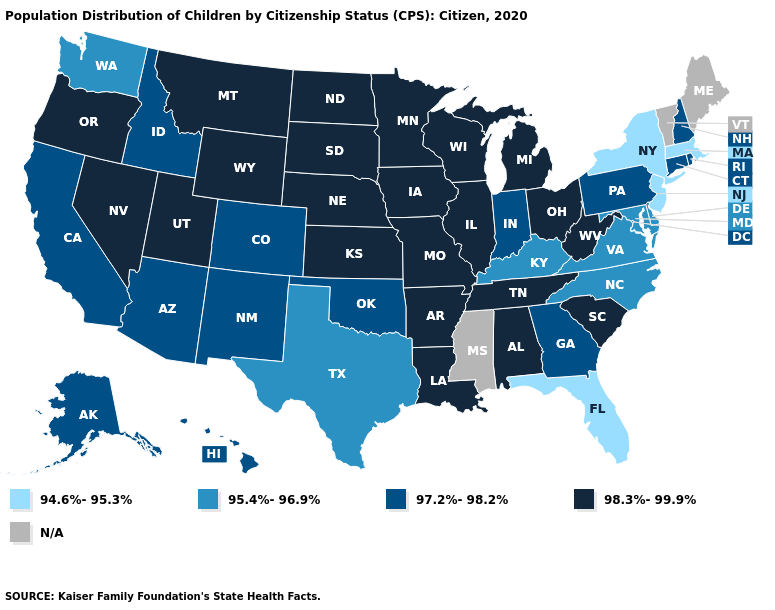Which states have the highest value in the USA?
Keep it brief. Alabama, Arkansas, Illinois, Iowa, Kansas, Louisiana, Michigan, Minnesota, Missouri, Montana, Nebraska, Nevada, North Dakota, Ohio, Oregon, South Carolina, South Dakota, Tennessee, Utah, West Virginia, Wisconsin, Wyoming. Among the states that border West Virginia , which have the lowest value?
Short answer required. Kentucky, Maryland, Virginia. Name the states that have a value in the range 94.6%-95.3%?
Write a very short answer. Florida, Massachusetts, New Jersey, New York. Which states have the lowest value in the West?
Write a very short answer. Washington. Name the states that have a value in the range N/A?
Quick response, please. Maine, Mississippi, Vermont. Which states have the lowest value in the South?
Answer briefly. Florida. Name the states that have a value in the range 98.3%-99.9%?
Answer briefly. Alabama, Arkansas, Illinois, Iowa, Kansas, Louisiana, Michigan, Minnesota, Missouri, Montana, Nebraska, Nevada, North Dakota, Ohio, Oregon, South Carolina, South Dakota, Tennessee, Utah, West Virginia, Wisconsin, Wyoming. What is the lowest value in the South?
Keep it brief. 94.6%-95.3%. What is the value of Rhode Island?
Answer briefly. 97.2%-98.2%. Name the states that have a value in the range 98.3%-99.9%?
Write a very short answer. Alabama, Arkansas, Illinois, Iowa, Kansas, Louisiana, Michigan, Minnesota, Missouri, Montana, Nebraska, Nevada, North Dakota, Ohio, Oregon, South Carolina, South Dakota, Tennessee, Utah, West Virginia, Wisconsin, Wyoming. What is the lowest value in states that border Florida?
Quick response, please. 97.2%-98.2%. What is the value of Pennsylvania?
Answer briefly. 97.2%-98.2%. Does Utah have the highest value in the West?
Write a very short answer. Yes. What is the highest value in states that border Oklahoma?
Be succinct. 98.3%-99.9%. What is the value of Idaho?
Be succinct. 97.2%-98.2%. 